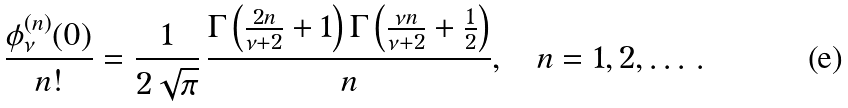Convert formula to latex. <formula><loc_0><loc_0><loc_500><loc_500>\frac { \phi ^ { ( n ) } _ { \nu } ( 0 ) } { n ! } = \frac { 1 } { 2 \sqrt { \pi } } \, \frac { \Gamma \left ( \frac { 2 n } { \nu + 2 } + 1 \right ) \Gamma \left ( \frac { \nu n } { \nu + 2 } + \frac { 1 } { 2 } \right ) } { n } , \quad n = 1 , 2 , \dots \, .</formula> 